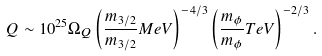<formula> <loc_0><loc_0><loc_500><loc_500>Q \sim 1 0 ^ { 2 5 } \Omega _ { Q } \left ( \frac { m _ { 3 / 2 } } { m _ { 3 / 2 } } { M e V } \right ) ^ { - 4 / 3 } \left ( \frac { m _ { \phi } } { m _ { \phi } } { T e V } \right ) ^ { - 2 / 3 } .</formula> 